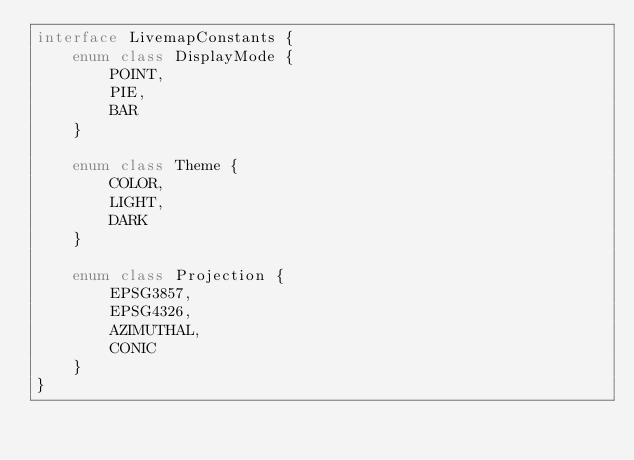Convert code to text. <code><loc_0><loc_0><loc_500><loc_500><_Kotlin_>interface LivemapConstants {
    enum class DisplayMode {
        POINT,
        PIE,
        BAR
    }

    enum class Theme {
        COLOR,
        LIGHT,
        DARK
    }

    enum class Projection {
        EPSG3857,
        EPSG4326,
        AZIMUTHAL,
        CONIC
    }
}</code> 